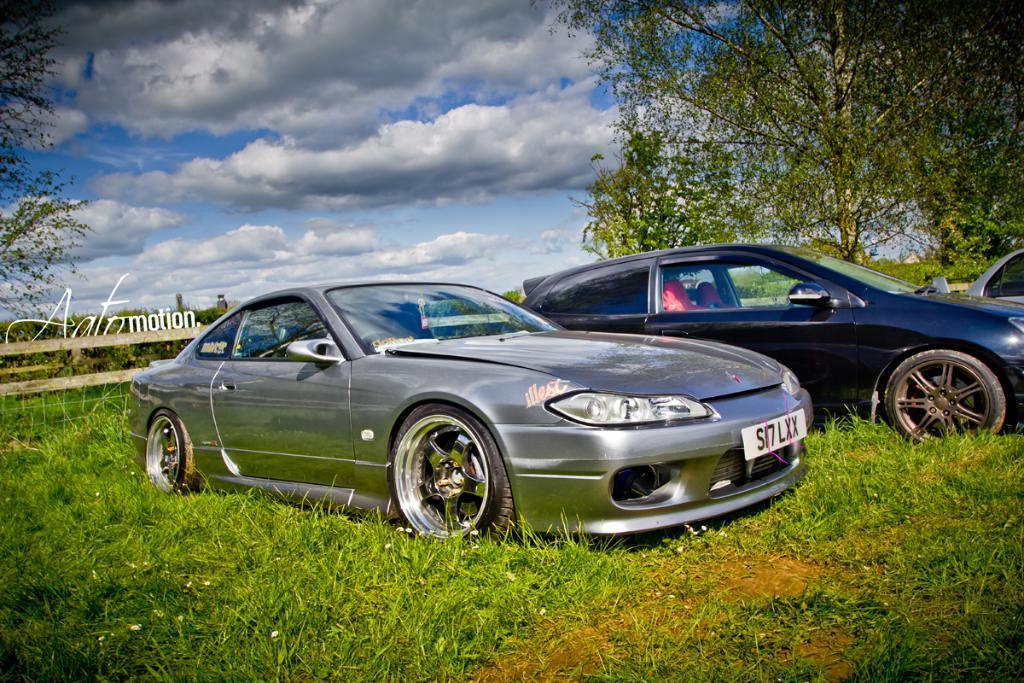In one or two sentences, can you explain what this image depicts? In the center of the image we can see grass on the ground. In the background there is fencing, trees, sky and clouds. 